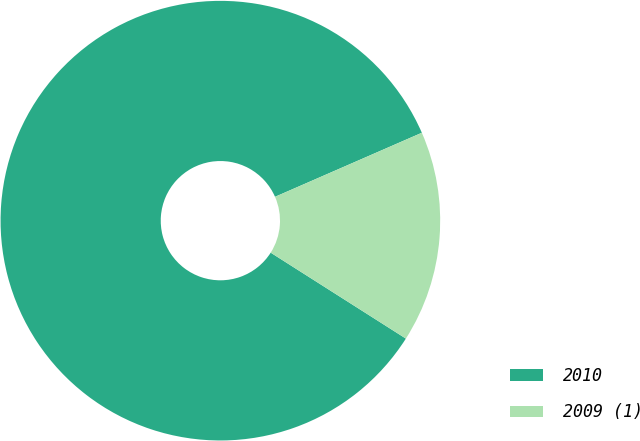Convert chart to OTSL. <chart><loc_0><loc_0><loc_500><loc_500><pie_chart><fcel>2010<fcel>2009 (1)<nl><fcel>84.44%<fcel>15.56%<nl></chart> 